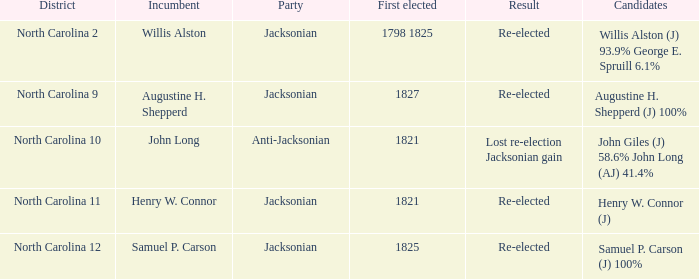Calculate the overall party percentage for willis alston (j) at 93.9% and george e. spruill at 6.1%. 1.0. 